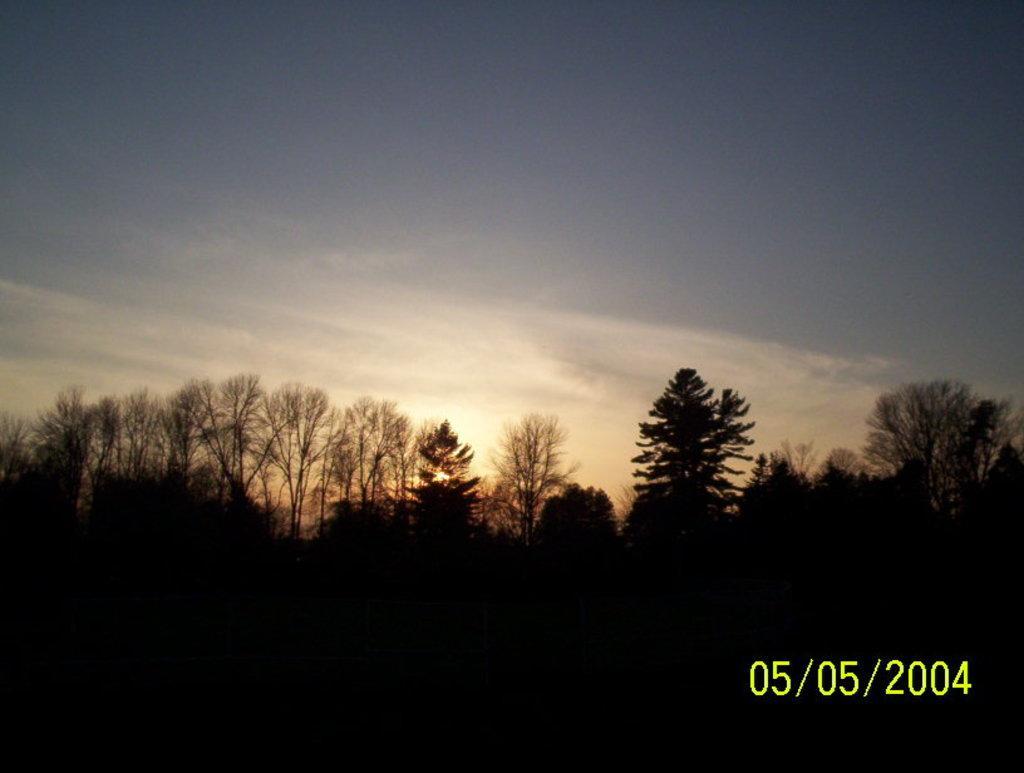Could you give a brief overview of what you see in this image? In this picture we can see trees and we can see sky in the background, in the bottom right we can see some numbers on it. 